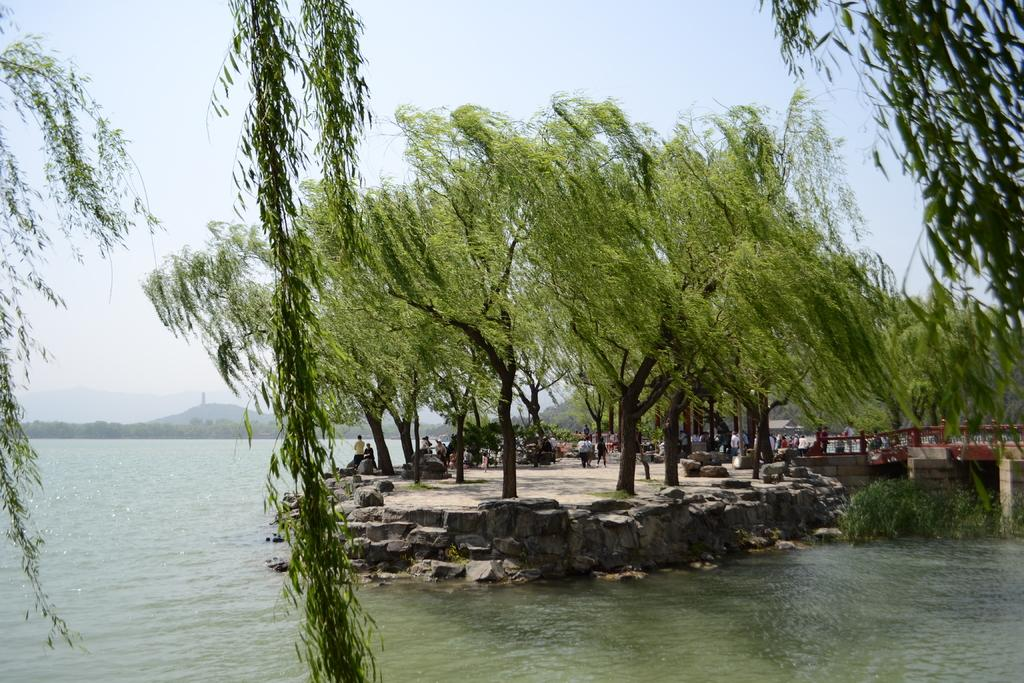How many people are present in the image? There are people in the image, but the exact number is not specified. What type of natural elements can be seen in the image? Trees, plants, rocks, water, and mountains are visible in the image. What type of man-made structure is present in the image? There is a bridge in the image. What part of the natural environment is visible in the background? Mountains and the sky are visible in the background. What type of visitor is present in the image? There is no mention of a visitor in the image. What type of system is responsible for the water flow in the image? There is no information about a system responsible for the water flow in the image. 